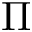<formula> <loc_0><loc_0><loc_500><loc_500>\Pi</formula> 